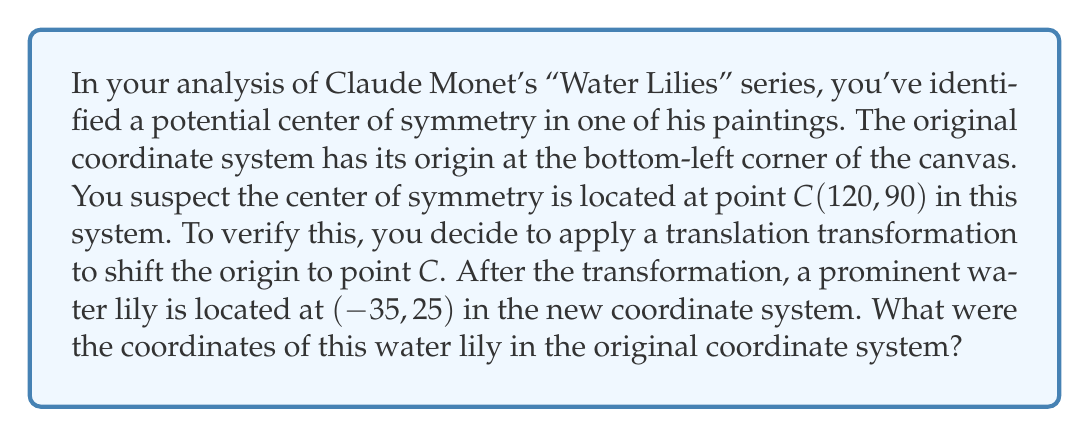Could you help me with this problem? To solve this problem, we need to understand the relationship between the original coordinate system and the transformed one. Let's approach this step-by-step:

1) The transformation applied is a translation that moves the origin to point $C(120, 90)$. This means that every point in the new coordinate system is shifted by $-120$ units horizontally and $-90$ units vertically relative to the original system.

2) We can express this transformation mathematically as:

   $x_{new} = x_{old} - 120$
   $y_{new} = y_{old} - 90$

3) We're given the coordinates of the water lily in the new system: $(-35, 25)$. Let's call the original coordinates $(x, y)$. We can set up two equations:

   $-35 = x - 120$
   $25 = y - 90$

4) To find the original coordinates, we need to solve these equations for $x$ and $y$:

   $x = -35 + 120 = 85$
   $y = 25 + 90 = 115$

5) Therefore, in the original coordinate system, the water lily was located at $(85, 115)$.

This method of using coordinate transformations is particularly useful in analyzing symmetry and composition in artworks, allowing art historians to quantify and precisely describe the structural elements of paintings.
Answer: The coordinates of the water lily in the original coordinate system were $(85, 115)$. 